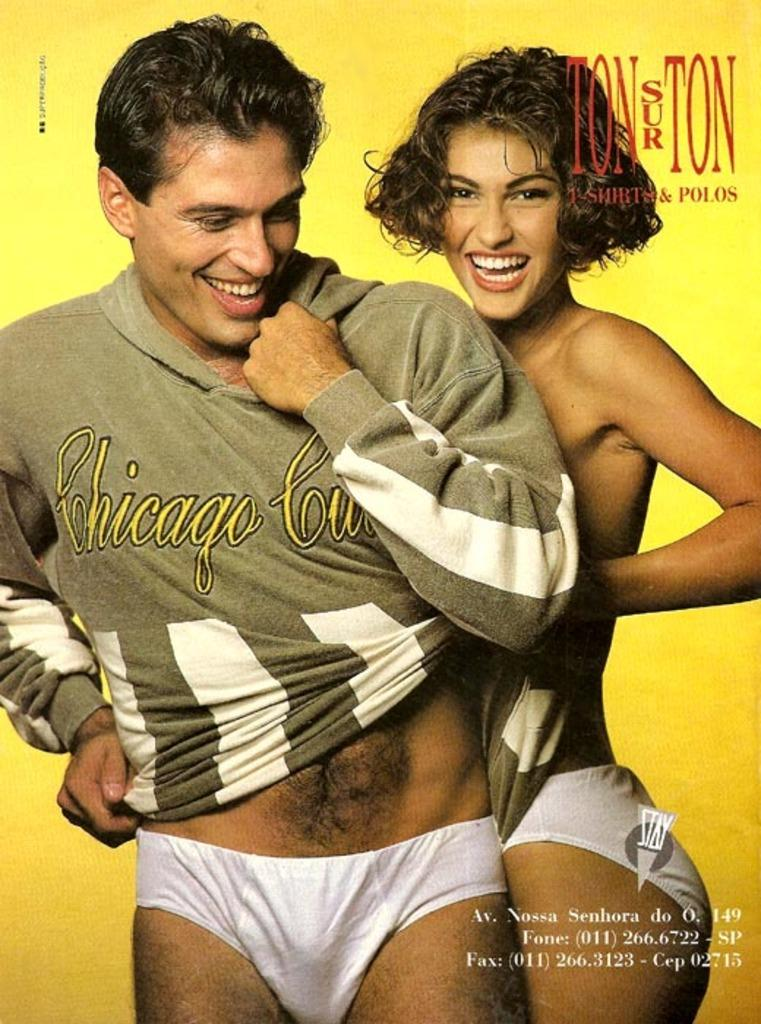How many people are in the image? There are two people in the image, a man and a woman. Where are the man and woman located in the image? Both the man and woman are standing in the middle of the image. What can be seen in the top right corner of the image? There is text in the top right corner of the image. What is present at the bottom of the image? There is text at the bottom of the image. What type of store can be seen in the background of the image? There is no store visible in the image; it only features a man and a woman standing in the middle of the image. 